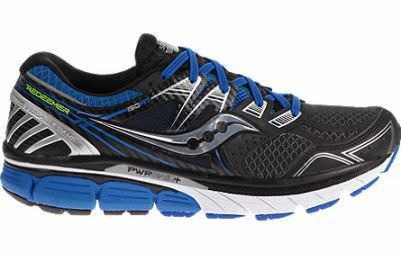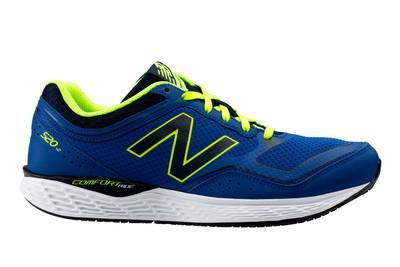The first image is the image on the left, the second image is the image on the right. Considering the images on both sides, is "Exactly one shoe has a blue heel." valid? Answer yes or no. Yes. 